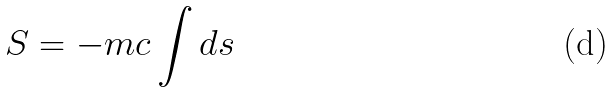Convert formula to latex. <formula><loc_0><loc_0><loc_500><loc_500>S = - m c \int d s</formula> 